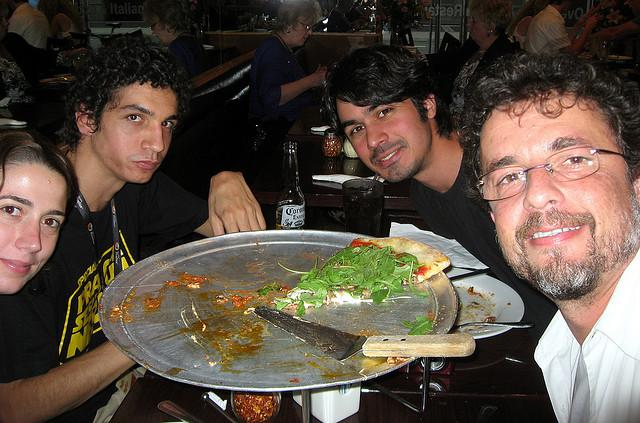What is covering the last slice of pizza available on the tray?

Choices:
A) pepperoni
B) mushrooms
C) spinach
D) cheese spinach 